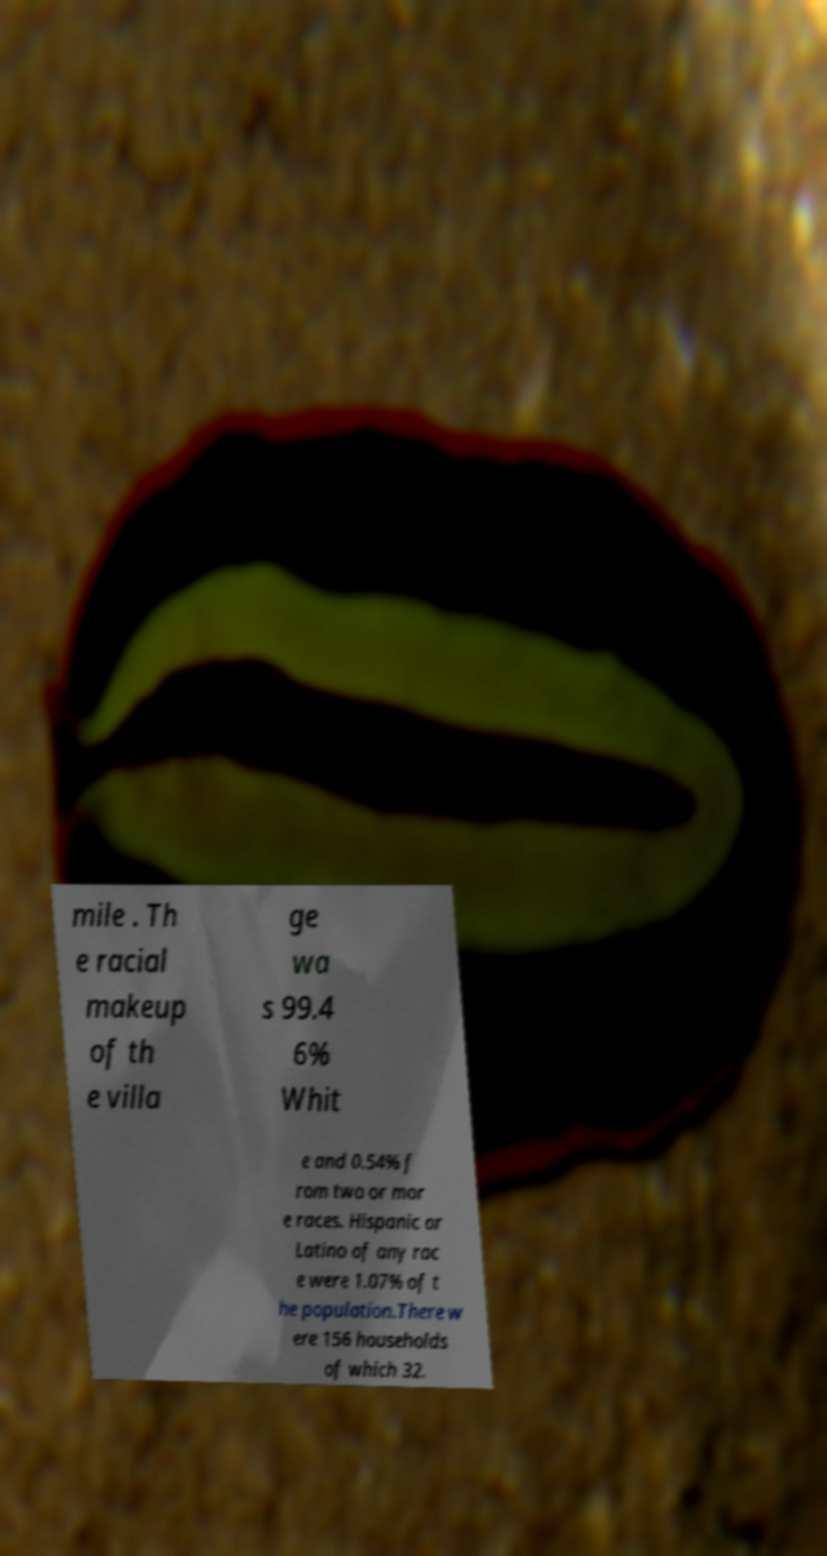Please identify and transcribe the text found in this image. mile . Th e racial makeup of th e villa ge wa s 99.4 6% Whit e and 0.54% f rom two or mor e races. Hispanic or Latino of any rac e were 1.07% of t he population.There w ere 156 households of which 32. 